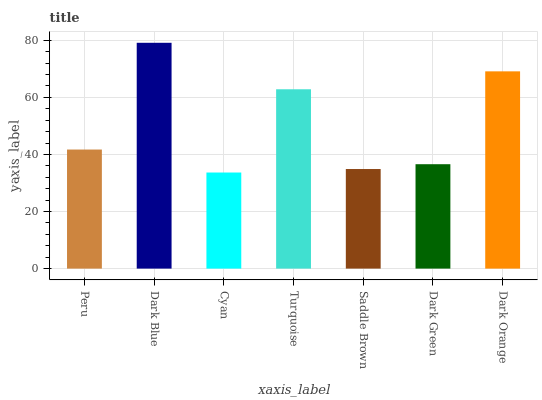Is Cyan the minimum?
Answer yes or no. Yes. Is Dark Blue the maximum?
Answer yes or no. Yes. Is Dark Blue the minimum?
Answer yes or no. No. Is Cyan the maximum?
Answer yes or no. No. Is Dark Blue greater than Cyan?
Answer yes or no. Yes. Is Cyan less than Dark Blue?
Answer yes or no. Yes. Is Cyan greater than Dark Blue?
Answer yes or no. No. Is Dark Blue less than Cyan?
Answer yes or no. No. Is Peru the high median?
Answer yes or no. Yes. Is Peru the low median?
Answer yes or no. Yes. Is Dark Blue the high median?
Answer yes or no. No. Is Dark Green the low median?
Answer yes or no. No. 